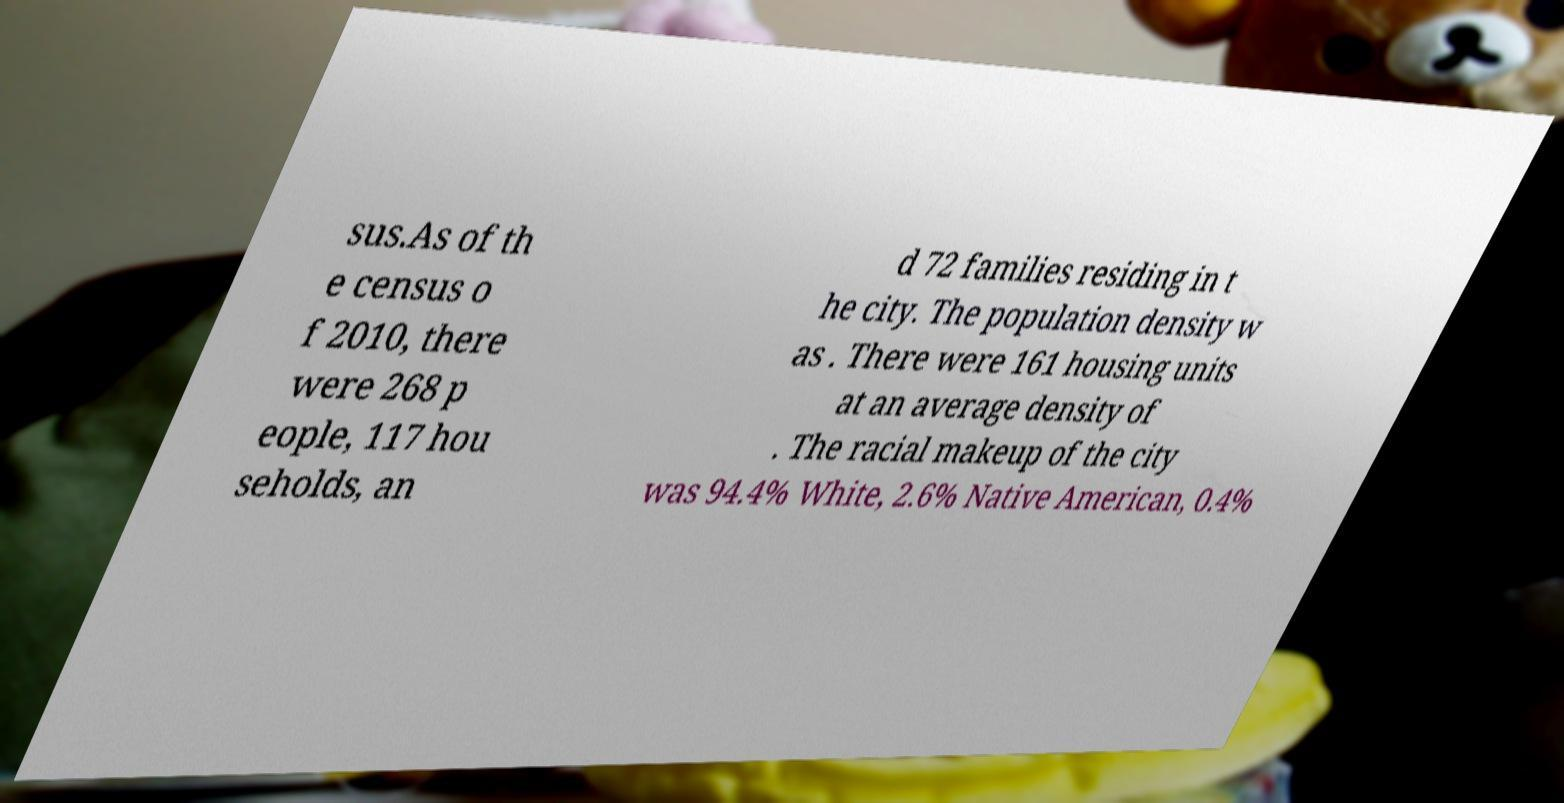What messages or text are displayed in this image? I need them in a readable, typed format. sus.As of th e census o f 2010, there were 268 p eople, 117 hou seholds, an d 72 families residing in t he city. The population density w as . There were 161 housing units at an average density of . The racial makeup of the city was 94.4% White, 2.6% Native American, 0.4% 